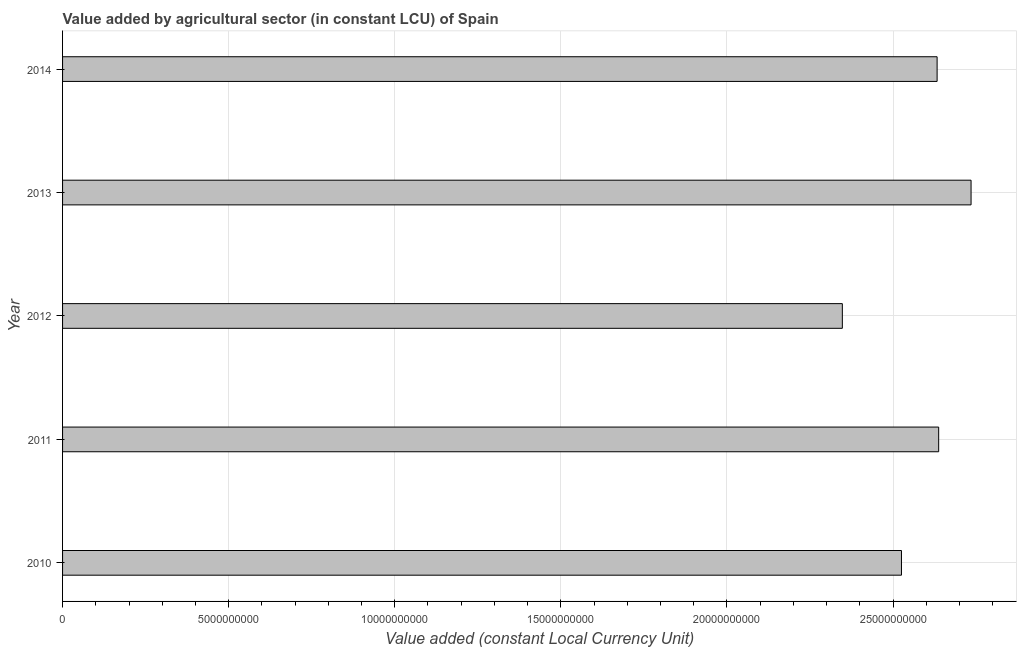Does the graph contain any zero values?
Give a very brief answer. No. What is the title of the graph?
Provide a short and direct response. Value added by agricultural sector (in constant LCU) of Spain. What is the label or title of the X-axis?
Ensure brevity in your answer.  Value added (constant Local Currency Unit). What is the label or title of the Y-axis?
Your answer should be compact. Year. What is the value added by agriculture sector in 2014?
Give a very brief answer. 2.63e+1. Across all years, what is the maximum value added by agriculture sector?
Provide a short and direct response. 2.73e+1. Across all years, what is the minimum value added by agriculture sector?
Provide a short and direct response. 2.35e+1. In which year was the value added by agriculture sector maximum?
Your answer should be compact. 2013. What is the sum of the value added by agriculture sector?
Your answer should be compact. 1.29e+11. What is the difference between the value added by agriculture sector in 2010 and 2012?
Offer a terse response. 1.78e+09. What is the average value added by agriculture sector per year?
Ensure brevity in your answer.  2.58e+1. What is the median value added by agriculture sector?
Offer a very short reply. 2.63e+1. What is the difference between the highest and the second highest value added by agriculture sector?
Offer a very short reply. 9.75e+08. What is the difference between the highest and the lowest value added by agriculture sector?
Keep it short and to the point. 3.88e+09. In how many years, is the value added by agriculture sector greater than the average value added by agriculture sector taken over all years?
Provide a succinct answer. 3. How many bars are there?
Provide a short and direct response. 5. Are the values on the major ticks of X-axis written in scientific E-notation?
Offer a very short reply. No. What is the Value added (constant Local Currency Unit) in 2010?
Offer a terse response. 2.53e+1. What is the Value added (constant Local Currency Unit) in 2011?
Ensure brevity in your answer.  2.64e+1. What is the Value added (constant Local Currency Unit) in 2012?
Ensure brevity in your answer.  2.35e+1. What is the Value added (constant Local Currency Unit) of 2013?
Provide a short and direct response. 2.73e+1. What is the Value added (constant Local Currency Unit) of 2014?
Keep it short and to the point. 2.63e+1. What is the difference between the Value added (constant Local Currency Unit) in 2010 and 2011?
Keep it short and to the point. -1.12e+09. What is the difference between the Value added (constant Local Currency Unit) in 2010 and 2012?
Provide a succinct answer. 1.78e+09. What is the difference between the Value added (constant Local Currency Unit) in 2010 and 2013?
Offer a terse response. -2.10e+09. What is the difference between the Value added (constant Local Currency Unit) in 2010 and 2014?
Keep it short and to the point. -1.07e+09. What is the difference between the Value added (constant Local Currency Unit) in 2011 and 2012?
Provide a short and direct response. 2.90e+09. What is the difference between the Value added (constant Local Currency Unit) in 2011 and 2013?
Ensure brevity in your answer.  -9.75e+08. What is the difference between the Value added (constant Local Currency Unit) in 2011 and 2014?
Your answer should be very brief. 4.70e+07. What is the difference between the Value added (constant Local Currency Unit) in 2012 and 2013?
Offer a very short reply. -3.88e+09. What is the difference between the Value added (constant Local Currency Unit) in 2012 and 2014?
Your response must be concise. -2.85e+09. What is the difference between the Value added (constant Local Currency Unit) in 2013 and 2014?
Your answer should be very brief. 1.02e+09. What is the ratio of the Value added (constant Local Currency Unit) in 2010 to that in 2011?
Your answer should be very brief. 0.96. What is the ratio of the Value added (constant Local Currency Unit) in 2010 to that in 2012?
Keep it short and to the point. 1.08. What is the ratio of the Value added (constant Local Currency Unit) in 2010 to that in 2013?
Keep it short and to the point. 0.92. What is the ratio of the Value added (constant Local Currency Unit) in 2011 to that in 2012?
Offer a terse response. 1.12. What is the ratio of the Value added (constant Local Currency Unit) in 2011 to that in 2014?
Your answer should be compact. 1. What is the ratio of the Value added (constant Local Currency Unit) in 2012 to that in 2013?
Keep it short and to the point. 0.86. What is the ratio of the Value added (constant Local Currency Unit) in 2012 to that in 2014?
Offer a very short reply. 0.89. What is the ratio of the Value added (constant Local Currency Unit) in 2013 to that in 2014?
Provide a succinct answer. 1.04. 